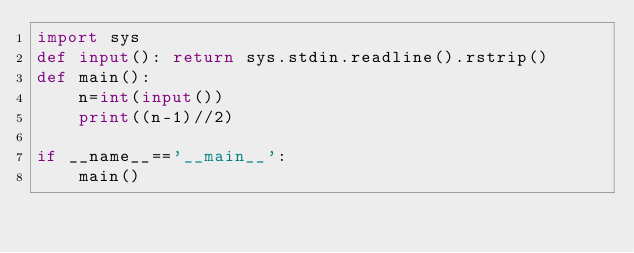Convert code to text. <code><loc_0><loc_0><loc_500><loc_500><_Python_>import sys
def input(): return sys.stdin.readline().rstrip()
def main():
    n=int(input())
    print((n-1)//2)

if __name__=='__main__':
    main()</code> 